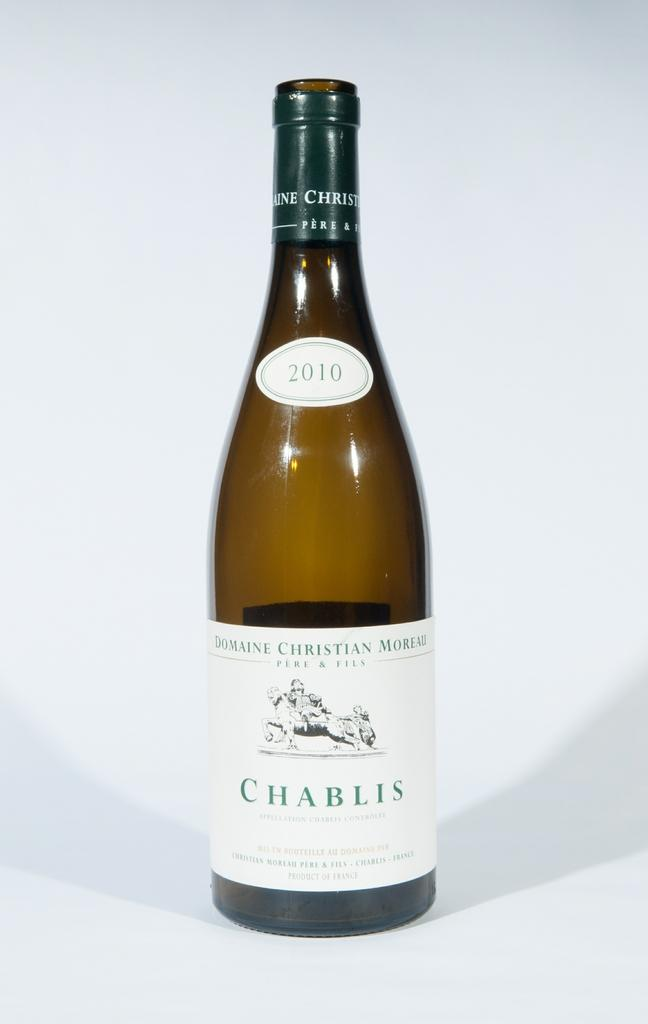<image>
Create a compact narrative representing the image presented. AN AMBER BOTTLE WITH WHITE LABLE OF CHABLIS 2010 WINE 